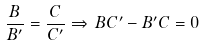<formula> <loc_0><loc_0><loc_500><loc_500>\frac { B } { B ^ { \prime } } = \frac { C } { C ^ { \prime } } \Rightarrow \, B C ^ { \prime } - B ^ { \prime } C = 0</formula> 